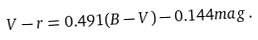Convert formula to latex. <formula><loc_0><loc_0><loc_500><loc_500>V - r = 0 . 4 9 1 ( B - V ) - 0 . 1 4 4 m a g \, .</formula> 